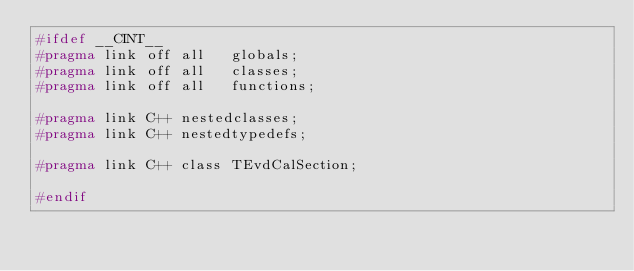<code> <loc_0><loc_0><loc_500><loc_500><_C_>#ifdef __CINT__
#pragma link off all   globals;
#pragma link off all   classes;
#pragma link off all   functions;

#pragma link C++ nestedclasses;
#pragma link C++ nestedtypedefs;

#pragma link C++ class TEvdCalSection;

#endif

</code> 